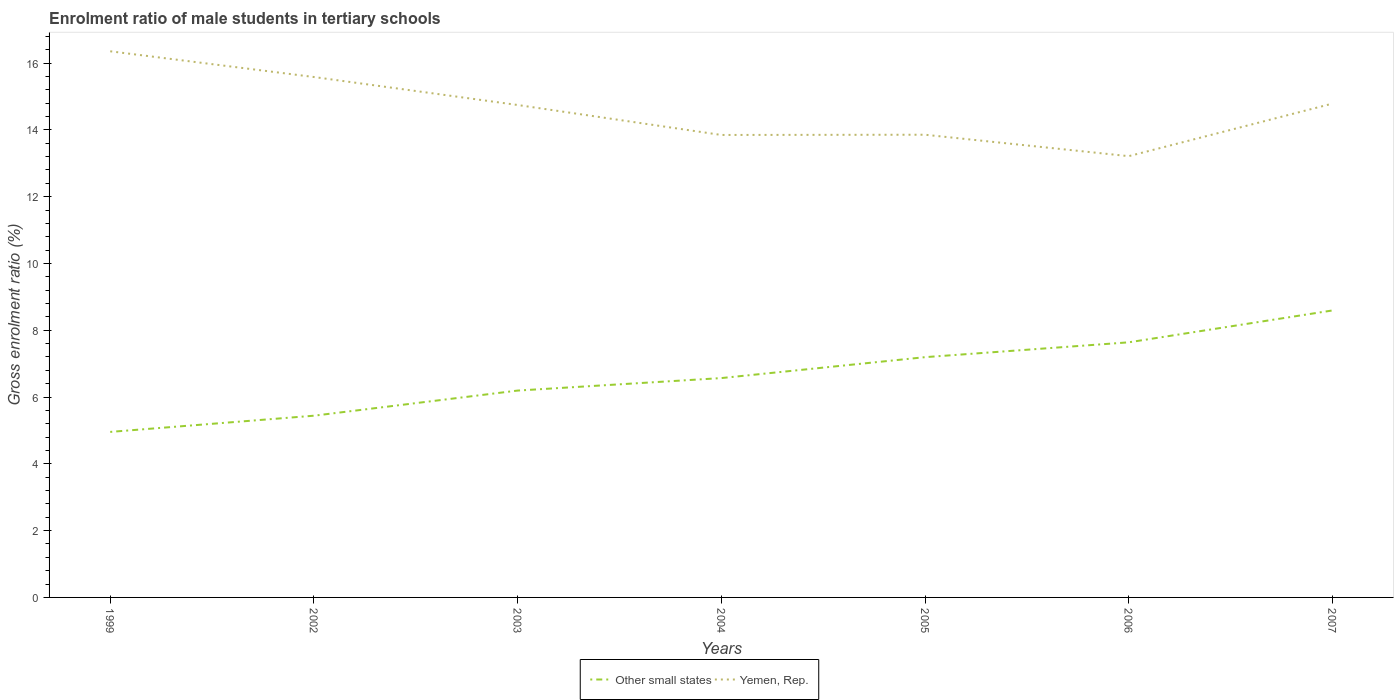Is the number of lines equal to the number of legend labels?
Provide a short and direct response. Yes. Across all years, what is the maximum enrolment ratio of male students in tertiary schools in Other small states?
Your answer should be compact. 4.96. What is the total enrolment ratio of male students in tertiary schools in Yemen, Rep. in the graph?
Offer a terse response. 2.5. What is the difference between the highest and the second highest enrolment ratio of male students in tertiary schools in Other small states?
Give a very brief answer. 3.64. How many years are there in the graph?
Offer a very short reply. 7. Does the graph contain grids?
Offer a terse response. No. Where does the legend appear in the graph?
Ensure brevity in your answer.  Bottom center. How many legend labels are there?
Your answer should be compact. 2. What is the title of the graph?
Provide a short and direct response. Enrolment ratio of male students in tertiary schools. What is the label or title of the X-axis?
Make the answer very short. Years. What is the label or title of the Y-axis?
Ensure brevity in your answer.  Gross enrolment ratio (%). What is the Gross enrolment ratio (%) of Other small states in 1999?
Give a very brief answer. 4.96. What is the Gross enrolment ratio (%) in Yemen, Rep. in 1999?
Offer a terse response. 16.35. What is the Gross enrolment ratio (%) of Other small states in 2002?
Keep it short and to the point. 5.44. What is the Gross enrolment ratio (%) of Yemen, Rep. in 2002?
Keep it short and to the point. 15.58. What is the Gross enrolment ratio (%) in Other small states in 2003?
Ensure brevity in your answer.  6.19. What is the Gross enrolment ratio (%) in Yemen, Rep. in 2003?
Provide a short and direct response. 14.74. What is the Gross enrolment ratio (%) of Other small states in 2004?
Keep it short and to the point. 6.57. What is the Gross enrolment ratio (%) in Yemen, Rep. in 2004?
Your answer should be very brief. 13.85. What is the Gross enrolment ratio (%) of Other small states in 2005?
Provide a succinct answer. 7.19. What is the Gross enrolment ratio (%) in Yemen, Rep. in 2005?
Give a very brief answer. 13.85. What is the Gross enrolment ratio (%) of Other small states in 2006?
Ensure brevity in your answer.  7.64. What is the Gross enrolment ratio (%) of Yemen, Rep. in 2006?
Ensure brevity in your answer.  13.21. What is the Gross enrolment ratio (%) in Other small states in 2007?
Ensure brevity in your answer.  8.59. What is the Gross enrolment ratio (%) of Yemen, Rep. in 2007?
Ensure brevity in your answer.  14.79. Across all years, what is the maximum Gross enrolment ratio (%) of Other small states?
Provide a succinct answer. 8.59. Across all years, what is the maximum Gross enrolment ratio (%) of Yemen, Rep.?
Your answer should be compact. 16.35. Across all years, what is the minimum Gross enrolment ratio (%) in Other small states?
Offer a terse response. 4.96. Across all years, what is the minimum Gross enrolment ratio (%) in Yemen, Rep.?
Keep it short and to the point. 13.21. What is the total Gross enrolment ratio (%) of Other small states in the graph?
Your response must be concise. 46.58. What is the total Gross enrolment ratio (%) of Yemen, Rep. in the graph?
Provide a short and direct response. 102.38. What is the difference between the Gross enrolment ratio (%) in Other small states in 1999 and that in 2002?
Your answer should be compact. -0.49. What is the difference between the Gross enrolment ratio (%) in Yemen, Rep. in 1999 and that in 2002?
Provide a short and direct response. 0.77. What is the difference between the Gross enrolment ratio (%) in Other small states in 1999 and that in 2003?
Give a very brief answer. -1.24. What is the difference between the Gross enrolment ratio (%) of Yemen, Rep. in 1999 and that in 2003?
Provide a short and direct response. 1.61. What is the difference between the Gross enrolment ratio (%) of Other small states in 1999 and that in 2004?
Your response must be concise. -1.61. What is the difference between the Gross enrolment ratio (%) in Yemen, Rep. in 1999 and that in 2004?
Keep it short and to the point. 2.51. What is the difference between the Gross enrolment ratio (%) of Other small states in 1999 and that in 2005?
Give a very brief answer. -2.24. What is the difference between the Gross enrolment ratio (%) of Yemen, Rep. in 1999 and that in 2005?
Provide a short and direct response. 2.5. What is the difference between the Gross enrolment ratio (%) of Other small states in 1999 and that in 2006?
Your response must be concise. -2.68. What is the difference between the Gross enrolment ratio (%) of Yemen, Rep. in 1999 and that in 2006?
Your answer should be compact. 3.14. What is the difference between the Gross enrolment ratio (%) of Other small states in 1999 and that in 2007?
Offer a very short reply. -3.64. What is the difference between the Gross enrolment ratio (%) of Yemen, Rep. in 1999 and that in 2007?
Give a very brief answer. 1.57. What is the difference between the Gross enrolment ratio (%) in Other small states in 2002 and that in 2003?
Your answer should be very brief. -0.75. What is the difference between the Gross enrolment ratio (%) in Yemen, Rep. in 2002 and that in 2003?
Provide a short and direct response. 0.84. What is the difference between the Gross enrolment ratio (%) in Other small states in 2002 and that in 2004?
Offer a terse response. -1.13. What is the difference between the Gross enrolment ratio (%) of Yemen, Rep. in 2002 and that in 2004?
Offer a terse response. 1.73. What is the difference between the Gross enrolment ratio (%) in Other small states in 2002 and that in 2005?
Give a very brief answer. -1.75. What is the difference between the Gross enrolment ratio (%) of Yemen, Rep. in 2002 and that in 2005?
Offer a very short reply. 1.73. What is the difference between the Gross enrolment ratio (%) in Other small states in 2002 and that in 2006?
Your answer should be very brief. -2.2. What is the difference between the Gross enrolment ratio (%) in Yemen, Rep. in 2002 and that in 2006?
Keep it short and to the point. 2.37. What is the difference between the Gross enrolment ratio (%) in Other small states in 2002 and that in 2007?
Your answer should be compact. -3.15. What is the difference between the Gross enrolment ratio (%) of Yemen, Rep. in 2002 and that in 2007?
Your answer should be very brief. 0.8. What is the difference between the Gross enrolment ratio (%) of Other small states in 2003 and that in 2004?
Provide a short and direct response. -0.37. What is the difference between the Gross enrolment ratio (%) of Yemen, Rep. in 2003 and that in 2004?
Provide a succinct answer. 0.9. What is the difference between the Gross enrolment ratio (%) of Other small states in 2003 and that in 2005?
Make the answer very short. -1. What is the difference between the Gross enrolment ratio (%) of Yemen, Rep. in 2003 and that in 2005?
Your answer should be compact. 0.89. What is the difference between the Gross enrolment ratio (%) of Other small states in 2003 and that in 2006?
Provide a short and direct response. -1.44. What is the difference between the Gross enrolment ratio (%) in Yemen, Rep. in 2003 and that in 2006?
Provide a succinct answer. 1.53. What is the difference between the Gross enrolment ratio (%) in Other small states in 2003 and that in 2007?
Make the answer very short. -2.4. What is the difference between the Gross enrolment ratio (%) in Yemen, Rep. in 2003 and that in 2007?
Offer a terse response. -0.04. What is the difference between the Gross enrolment ratio (%) of Other small states in 2004 and that in 2005?
Offer a terse response. -0.63. What is the difference between the Gross enrolment ratio (%) of Yemen, Rep. in 2004 and that in 2005?
Make the answer very short. -0.01. What is the difference between the Gross enrolment ratio (%) in Other small states in 2004 and that in 2006?
Offer a terse response. -1.07. What is the difference between the Gross enrolment ratio (%) in Yemen, Rep. in 2004 and that in 2006?
Provide a short and direct response. 0.64. What is the difference between the Gross enrolment ratio (%) in Other small states in 2004 and that in 2007?
Give a very brief answer. -2.02. What is the difference between the Gross enrolment ratio (%) in Yemen, Rep. in 2004 and that in 2007?
Provide a short and direct response. -0.94. What is the difference between the Gross enrolment ratio (%) of Other small states in 2005 and that in 2006?
Make the answer very short. -0.44. What is the difference between the Gross enrolment ratio (%) of Yemen, Rep. in 2005 and that in 2006?
Your response must be concise. 0.64. What is the difference between the Gross enrolment ratio (%) in Other small states in 2005 and that in 2007?
Provide a short and direct response. -1.4. What is the difference between the Gross enrolment ratio (%) of Yemen, Rep. in 2005 and that in 2007?
Your answer should be compact. -0.93. What is the difference between the Gross enrolment ratio (%) in Other small states in 2006 and that in 2007?
Give a very brief answer. -0.95. What is the difference between the Gross enrolment ratio (%) in Yemen, Rep. in 2006 and that in 2007?
Your answer should be compact. -1.57. What is the difference between the Gross enrolment ratio (%) of Other small states in 1999 and the Gross enrolment ratio (%) of Yemen, Rep. in 2002?
Ensure brevity in your answer.  -10.63. What is the difference between the Gross enrolment ratio (%) in Other small states in 1999 and the Gross enrolment ratio (%) in Yemen, Rep. in 2003?
Provide a succinct answer. -9.79. What is the difference between the Gross enrolment ratio (%) in Other small states in 1999 and the Gross enrolment ratio (%) in Yemen, Rep. in 2004?
Provide a succinct answer. -8.89. What is the difference between the Gross enrolment ratio (%) in Other small states in 1999 and the Gross enrolment ratio (%) in Yemen, Rep. in 2005?
Give a very brief answer. -8.9. What is the difference between the Gross enrolment ratio (%) of Other small states in 1999 and the Gross enrolment ratio (%) of Yemen, Rep. in 2006?
Give a very brief answer. -8.26. What is the difference between the Gross enrolment ratio (%) in Other small states in 1999 and the Gross enrolment ratio (%) in Yemen, Rep. in 2007?
Your answer should be compact. -9.83. What is the difference between the Gross enrolment ratio (%) in Other small states in 2002 and the Gross enrolment ratio (%) in Yemen, Rep. in 2003?
Your answer should be compact. -9.3. What is the difference between the Gross enrolment ratio (%) of Other small states in 2002 and the Gross enrolment ratio (%) of Yemen, Rep. in 2004?
Ensure brevity in your answer.  -8.41. What is the difference between the Gross enrolment ratio (%) in Other small states in 2002 and the Gross enrolment ratio (%) in Yemen, Rep. in 2005?
Your answer should be very brief. -8.41. What is the difference between the Gross enrolment ratio (%) in Other small states in 2002 and the Gross enrolment ratio (%) in Yemen, Rep. in 2006?
Make the answer very short. -7.77. What is the difference between the Gross enrolment ratio (%) in Other small states in 2002 and the Gross enrolment ratio (%) in Yemen, Rep. in 2007?
Ensure brevity in your answer.  -9.34. What is the difference between the Gross enrolment ratio (%) in Other small states in 2003 and the Gross enrolment ratio (%) in Yemen, Rep. in 2004?
Provide a short and direct response. -7.65. What is the difference between the Gross enrolment ratio (%) in Other small states in 2003 and the Gross enrolment ratio (%) in Yemen, Rep. in 2005?
Provide a short and direct response. -7.66. What is the difference between the Gross enrolment ratio (%) in Other small states in 2003 and the Gross enrolment ratio (%) in Yemen, Rep. in 2006?
Offer a very short reply. -7.02. What is the difference between the Gross enrolment ratio (%) of Other small states in 2003 and the Gross enrolment ratio (%) of Yemen, Rep. in 2007?
Your response must be concise. -8.59. What is the difference between the Gross enrolment ratio (%) of Other small states in 2004 and the Gross enrolment ratio (%) of Yemen, Rep. in 2005?
Offer a terse response. -7.29. What is the difference between the Gross enrolment ratio (%) in Other small states in 2004 and the Gross enrolment ratio (%) in Yemen, Rep. in 2006?
Offer a very short reply. -6.64. What is the difference between the Gross enrolment ratio (%) of Other small states in 2004 and the Gross enrolment ratio (%) of Yemen, Rep. in 2007?
Keep it short and to the point. -8.22. What is the difference between the Gross enrolment ratio (%) of Other small states in 2005 and the Gross enrolment ratio (%) of Yemen, Rep. in 2006?
Make the answer very short. -6.02. What is the difference between the Gross enrolment ratio (%) in Other small states in 2005 and the Gross enrolment ratio (%) in Yemen, Rep. in 2007?
Give a very brief answer. -7.59. What is the difference between the Gross enrolment ratio (%) of Other small states in 2006 and the Gross enrolment ratio (%) of Yemen, Rep. in 2007?
Keep it short and to the point. -7.15. What is the average Gross enrolment ratio (%) in Other small states per year?
Your answer should be compact. 6.65. What is the average Gross enrolment ratio (%) in Yemen, Rep. per year?
Your response must be concise. 14.63. In the year 1999, what is the difference between the Gross enrolment ratio (%) of Other small states and Gross enrolment ratio (%) of Yemen, Rep.?
Your response must be concise. -11.4. In the year 2002, what is the difference between the Gross enrolment ratio (%) of Other small states and Gross enrolment ratio (%) of Yemen, Rep.?
Provide a short and direct response. -10.14. In the year 2003, what is the difference between the Gross enrolment ratio (%) of Other small states and Gross enrolment ratio (%) of Yemen, Rep.?
Provide a succinct answer. -8.55. In the year 2004, what is the difference between the Gross enrolment ratio (%) of Other small states and Gross enrolment ratio (%) of Yemen, Rep.?
Your answer should be very brief. -7.28. In the year 2005, what is the difference between the Gross enrolment ratio (%) of Other small states and Gross enrolment ratio (%) of Yemen, Rep.?
Make the answer very short. -6.66. In the year 2006, what is the difference between the Gross enrolment ratio (%) of Other small states and Gross enrolment ratio (%) of Yemen, Rep.?
Provide a short and direct response. -5.57. In the year 2007, what is the difference between the Gross enrolment ratio (%) in Other small states and Gross enrolment ratio (%) in Yemen, Rep.?
Ensure brevity in your answer.  -6.19. What is the ratio of the Gross enrolment ratio (%) in Other small states in 1999 to that in 2002?
Offer a very short reply. 0.91. What is the ratio of the Gross enrolment ratio (%) in Yemen, Rep. in 1999 to that in 2002?
Ensure brevity in your answer.  1.05. What is the ratio of the Gross enrolment ratio (%) of Other small states in 1999 to that in 2003?
Your answer should be very brief. 0.8. What is the ratio of the Gross enrolment ratio (%) of Yemen, Rep. in 1999 to that in 2003?
Provide a succinct answer. 1.11. What is the ratio of the Gross enrolment ratio (%) of Other small states in 1999 to that in 2004?
Ensure brevity in your answer.  0.75. What is the ratio of the Gross enrolment ratio (%) in Yemen, Rep. in 1999 to that in 2004?
Keep it short and to the point. 1.18. What is the ratio of the Gross enrolment ratio (%) in Other small states in 1999 to that in 2005?
Provide a succinct answer. 0.69. What is the ratio of the Gross enrolment ratio (%) of Yemen, Rep. in 1999 to that in 2005?
Make the answer very short. 1.18. What is the ratio of the Gross enrolment ratio (%) in Other small states in 1999 to that in 2006?
Your answer should be very brief. 0.65. What is the ratio of the Gross enrolment ratio (%) of Yemen, Rep. in 1999 to that in 2006?
Provide a succinct answer. 1.24. What is the ratio of the Gross enrolment ratio (%) in Other small states in 1999 to that in 2007?
Offer a very short reply. 0.58. What is the ratio of the Gross enrolment ratio (%) in Yemen, Rep. in 1999 to that in 2007?
Offer a very short reply. 1.11. What is the ratio of the Gross enrolment ratio (%) of Other small states in 2002 to that in 2003?
Give a very brief answer. 0.88. What is the ratio of the Gross enrolment ratio (%) of Yemen, Rep. in 2002 to that in 2003?
Make the answer very short. 1.06. What is the ratio of the Gross enrolment ratio (%) of Other small states in 2002 to that in 2004?
Your answer should be very brief. 0.83. What is the ratio of the Gross enrolment ratio (%) in Yemen, Rep. in 2002 to that in 2004?
Provide a short and direct response. 1.13. What is the ratio of the Gross enrolment ratio (%) of Other small states in 2002 to that in 2005?
Ensure brevity in your answer.  0.76. What is the ratio of the Gross enrolment ratio (%) in Yemen, Rep. in 2002 to that in 2005?
Make the answer very short. 1.12. What is the ratio of the Gross enrolment ratio (%) in Other small states in 2002 to that in 2006?
Give a very brief answer. 0.71. What is the ratio of the Gross enrolment ratio (%) in Yemen, Rep. in 2002 to that in 2006?
Make the answer very short. 1.18. What is the ratio of the Gross enrolment ratio (%) in Other small states in 2002 to that in 2007?
Your answer should be very brief. 0.63. What is the ratio of the Gross enrolment ratio (%) in Yemen, Rep. in 2002 to that in 2007?
Provide a succinct answer. 1.05. What is the ratio of the Gross enrolment ratio (%) of Other small states in 2003 to that in 2004?
Offer a terse response. 0.94. What is the ratio of the Gross enrolment ratio (%) of Yemen, Rep. in 2003 to that in 2004?
Your answer should be compact. 1.06. What is the ratio of the Gross enrolment ratio (%) of Other small states in 2003 to that in 2005?
Ensure brevity in your answer.  0.86. What is the ratio of the Gross enrolment ratio (%) of Yemen, Rep. in 2003 to that in 2005?
Your response must be concise. 1.06. What is the ratio of the Gross enrolment ratio (%) of Other small states in 2003 to that in 2006?
Keep it short and to the point. 0.81. What is the ratio of the Gross enrolment ratio (%) of Yemen, Rep. in 2003 to that in 2006?
Make the answer very short. 1.12. What is the ratio of the Gross enrolment ratio (%) in Other small states in 2003 to that in 2007?
Your answer should be very brief. 0.72. What is the ratio of the Gross enrolment ratio (%) of Other small states in 2004 to that in 2006?
Ensure brevity in your answer.  0.86. What is the ratio of the Gross enrolment ratio (%) of Yemen, Rep. in 2004 to that in 2006?
Make the answer very short. 1.05. What is the ratio of the Gross enrolment ratio (%) in Other small states in 2004 to that in 2007?
Make the answer very short. 0.76. What is the ratio of the Gross enrolment ratio (%) in Yemen, Rep. in 2004 to that in 2007?
Your answer should be very brief. 0.94. What is the ratio of the Gross enrolment ratio (%) of Other small states in 2005 to that in 2006?
Your response must be concise. 0.94. What is the ratio of the Gross enrolment ratio (%) of Yemen, Rep. in 2005 to that in 2006?
Ensure brevity in your answer.  1.05. What is the ratio of the Gross enrolment ratio (%) in Other small states in 2005 to that in 2007?
Your answer should be compact. 0.84. What is the ratio of the Gross enrolment ratio (%) of Yemen, Rep. in 2005 to that in 2007?
Ensure brevity in your answer.  0.94. What is the ratio of the Gross enrolment ratio (%) of Other small states in 2006 to that in 2007?
Give a very brief answer. 0.89. What is the ratio of the Gross enrolment ratio (%) of Yemen, Rep. in 2006 to that in 2007?
Provide a short and direct response. 0.89. What is the difference between the highest and the second highest Gross enrolment ratio (%) in Other small states?
Your answer should be compact. 0.95. What is the difference between the highest and the second highest Gross enrolment ratio (%) in Yemen, Rep.?
Your response must be concise. 0.77. What is the difference between the highest and the lowest Gross enrolment ratio (%) in Other small states?
Provide a succinct answer. 3.64. What is the difference between the highest and the lowest Gross enrolment ratio (%) in Yemen, Rep.?
Your answer should be very brief. 3.14. 